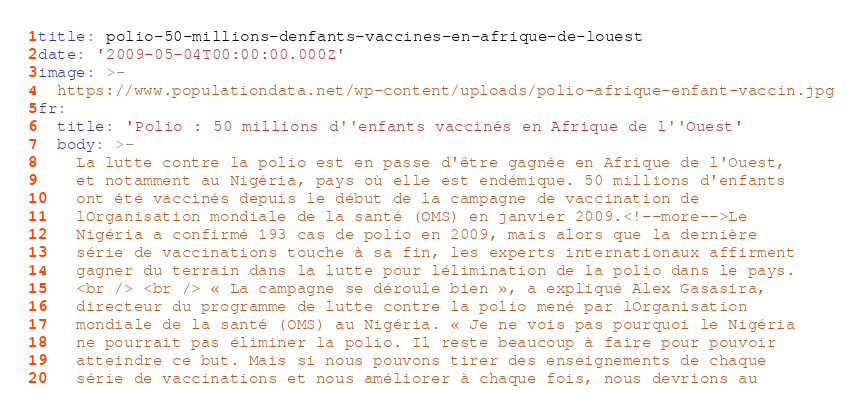<code> <loc_0><loc_0><loc_500><loc_500><_YAML_>title: polio-50-millions-denfants-vaccines-en-afrique-de-louest
date: '2009-05-04T00:00:00.000Z'
image: >-
  https://www.populationdata.net/wp-content/uploads/polio-afrique-enfant-vaccin.jpg
fr:
  title: 'Polio : 50 millions d''enfants vaccinés en Afrique de l''Ouest'
  body: >-
    La lutte contre la polio est en passe d'être gagnée en Afrique de l'Ouest,
    et notamment au Nigéria, pays où elle est endémique. 50 millions d'enfants
    ont été vaccinés depuis le début de la campagne de vaccination de
    lOrganisation mondiale de la santé (OMS) en janvier 2009.<!--more-->Le
    Nigéria a confirmé 193 cas de polio en 2009, mais alors que la dernière
    série de vaccinations touche à sa fin, les experts internationaux affirment
    gagner du terrain dans la lutte pour lélimination de la polio dans le pays.
    <br /> <br /> « La campagne se déroule bien », a expliqué Alex Gasasira,
    directeur du programme de lutte contre la polio mené par lOrganisation
    mondiale de la santé (OMS) au Nigéria. « Je ne vois pas pourquoi le Nigéria
    ne pourrait pas éliminer la polio. Il reste beaucoup à faire pour pouvoir
    atteindre ce but. Mais si nous pouvons tirer des enseignements de chaque
    série de vaccinations et nous améliorer à chaque fois, nous devrions au</code> 